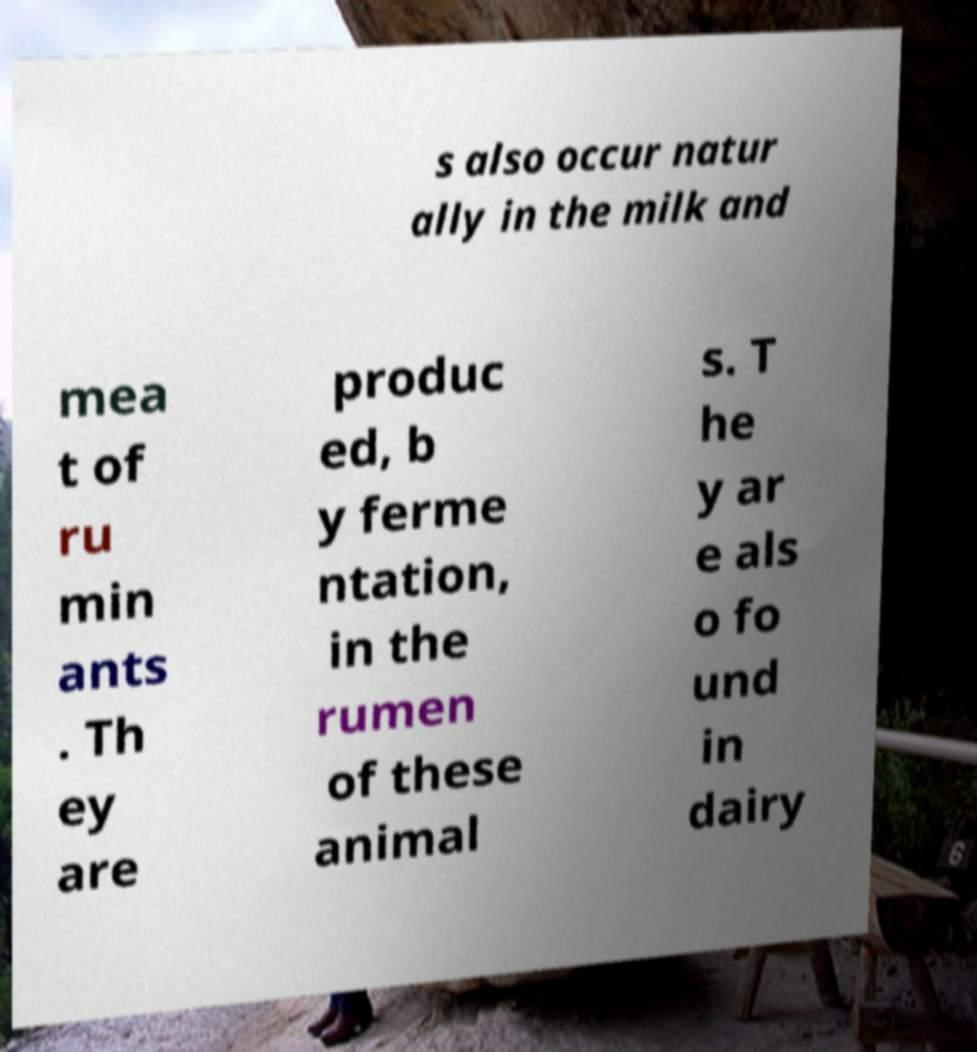There's text embedded in this image that I need extracted. Can you transcribe it verbatim? s also occur natur ally in the milk and mea t of ru min ants . Th ey are produc ed, b y ferme ntation, in the rumen of these animal s. T he y ar e als o fo und in dairy 